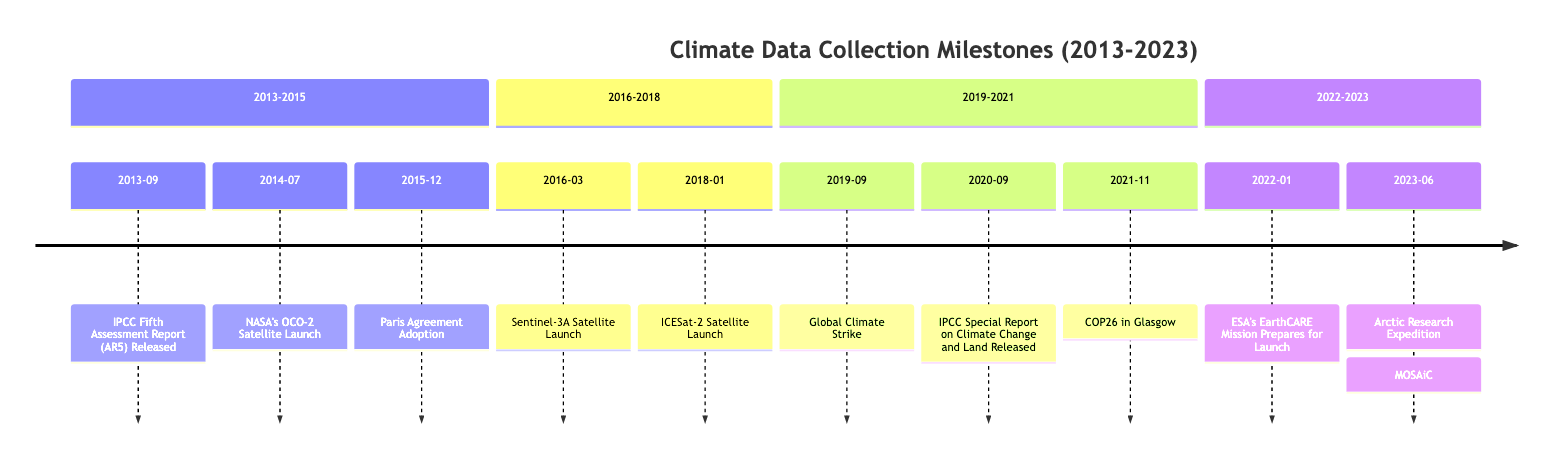What major climate conference was held in 2021? The diagram indicates that COP26 in Glasgow occurred in November 2021. This event is labeled directly within the timeline.
Answer: COP26 in Glasgow How many satellite launches are listed between 2013 and 2018? By examining the timeline sections from 2013 to 2018, there are three satellite launches: NASA’s OCO-2, Sentinel-3A, and ICESat-2.
Answer: 3 What was the focus of the IPCC Special Report released in September 2020? The timeline description for the IPCC Special Report on Climate Change and Land indicates that it focused on the interplay between climate change and land use, including food security and sustainability.
Answer: Climate Change and Land Which satellite was launched first, ICESat-2 or Sentinel-3A? From the timeline, Sentinel-3A was launched in March 2016, while ICESat-2 was launched in January 2018. Therefore, Sentinel-3A was launched first.
Answer: Sentinel-3A What event marked the global adoption of a climate accord in December 2015? The timeline explicitly notes the adoption of the Paris Agreement during COP21 in December 2015, which is labeled within the diagram.
Answer: Paris Agreement Adoption What significant international movement occurred in September 2019? The timeline notes the Global Climate Strike took place in September 2019, which is highlighted as an important event.
Answer: Global Climate Strike What critical data expedition was completed in June 2023? The timeline indicates that the Arctic Research Expedition named MOSAiC was completed in June 2023, providing extensive climate data.
Answer: MOSAiC Which satellite mission from ESA aimed to improve understanding of clouds and aerosols? The EarthCARE mission, preparation for which is mentioned in January 2022 on the timeline, aims to enhance understanding of the role clouds and aerosols play in climate.
Answer: EarthCARE Mission What important report was released in 2013? The IPCC Fifth Assessment Report (AR5) was released in September 2013, as indicated in the timeline.
Answer: IPCC Fifth Assessment Report (AR5) 